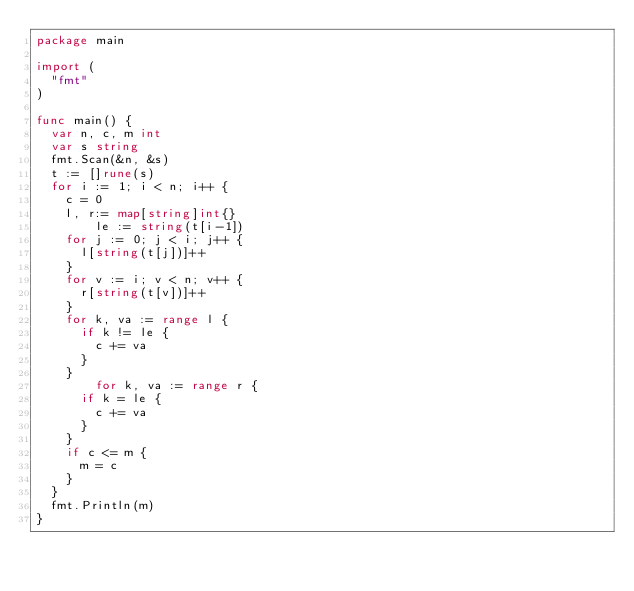<code> <loc_0><loc_0><loc_500><loc_500><_Go_>package main
 
import (
	"fmt"
)
 
func main() {
	var n, c, m int
	var s string
	fmt.Scan(&n, &s)
	t := []rune(s)
	for i := 1; i < n; i++ {
		c = 0
		l, r:= map[string]int{}
      	le := string(t[i-1])
		for j := 0; j < i; j++ {
			l[string(t[j])]++
		}
		for v := i; v < n; v++ {
			r[string(t[v])]++
		}
		for k, va := range l {
			if k != le {
				c += va
			}
		}
      	for k, va := range r {
			if k = le {
				c += va
			}
		}
		if c <= m {
			m = c
		}
	}
	fmt.Println(m)
}</code> 